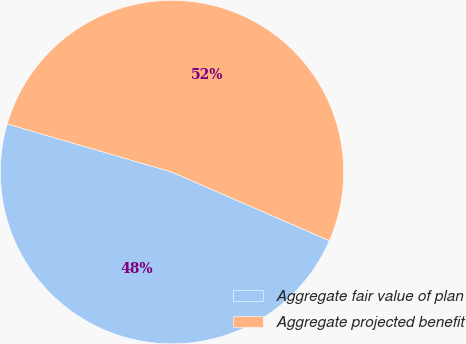<chart> <loc_0><loc_0><loc_500><loc_500><pie_chart><fcel>Aggregate fair value of plan<fcel>Aggregate projected benefit<nl><fcel>47.99%<fcel>52.01%<nl></chart> 